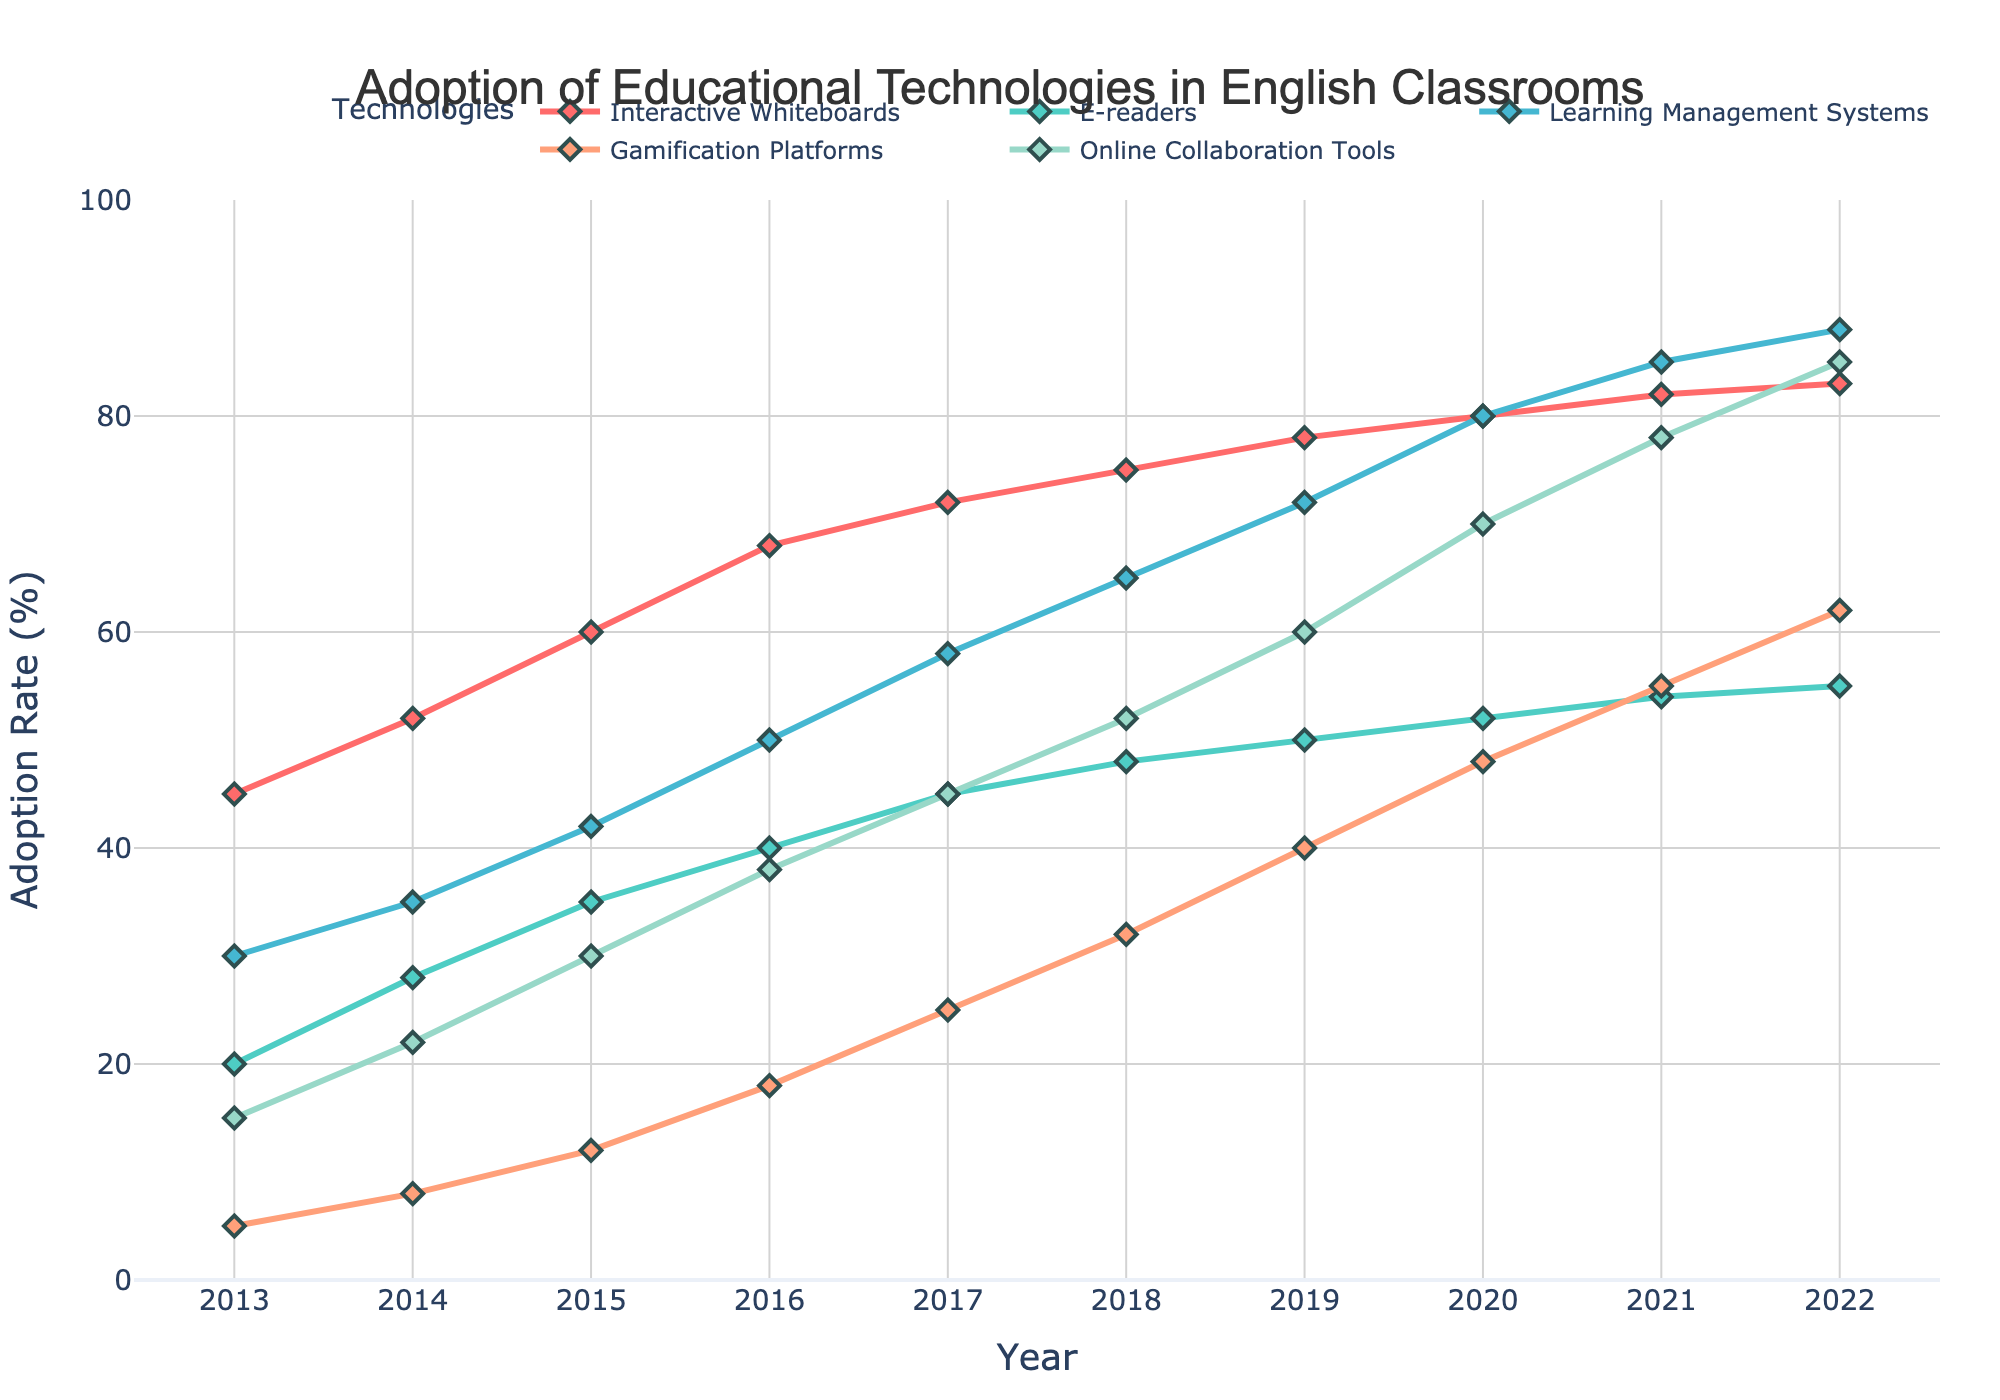Which technology had the highest adoption rate in 2013? In 2013, Interactive Whiteboards had the highest adoption rate at 45%.
Answer: Interactive Whiteboards Did Online Collaboration Tools ever surpass Gamification Platforms in adoption rates? If so, in which year? Yes, Online Collaboration Tools surpassed Gamification Platforms in 2016, when Online Collaboration Tools had a 38% adoption rate compared to 18% for Gamification Platforms.
Answer: 2016 By how many percentage points did the adoption rate of E-readers increase from 2013 to 2022? The adoption rate for E-readers in 2013 was 20%, and in 2022, it was 55%. The increase is computed by subtracting the two values: 55% - 20% = 35%.
Answer: 35% Calculate the average adoption rate of Learning Management Systems from 2013 to 2017. The adoption rates for Learning Management Systems from 2013 to 2017 are 30%, 35%, 42%, 50%, and 58%. Adding these values gives 215. The average is then 215 / 5 = 43%.
Answer: 43% Which technology showed the most consistent increase in adoption rate every year? Each technology shows a consistent increase, but Interactive Whiteboards show a steady upward trend every year from 45% in 2013 to 83% in 2022.
Answer: Interactive Whiteboards Compare the adoption rates of Gamification Platforms and Online Collaboration Tools in 2019. Which was higher and by how much? In 2019, Gamification Platforms had a 40% adoption rate, and Online Collaboration Tools had a 60% adoption rate. 60% - 40% = 20%, so Online Collaboration Tools had a 20 percentage point higher adoption rate.
Answer: Online Collaboration Tools by 20% What is the total increase in adoption rate of Learning Management Systems from 2013 to 2022? The adoption rate for Learning Management Systems in 2013 was 30%, and in 2022, it was 88%. The total increase is 88% - 30% = 58%.
Answer: 58% Which two technologies had the closest adoption rates in 2020, and what were those rates? In 2020, E-readers and Gamification Platforms had close adoption rates of 52% and 48%, respectively. The rates are close to each other with a difference of 4%.
Answer: E-readers (52%) and Gamification Platforms (48%) In 2016, what is the difference between the adoption rates of the two technologies with the highest adoption rates? In 2016, the two technologies with the highest adoption rates are Interactive Whiteboards (68%) and Learning Management Systems (50%). The difference is 68% - 50% = 18%.
Answer: 18% What trend can be observed in the adoption rate of Interactive Whiteboards over the decade? The adoption rate of Interactive Whiteboards showed a steady increase every year from 45% in 2013 to 83% in 2022. This indicates a consistently growing trend without any decline.
Answer: Steady increase 